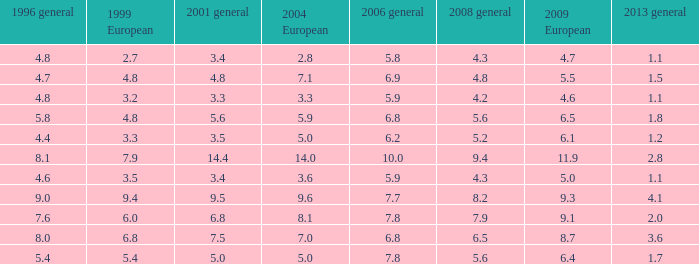How many values for 1999 European correspond to a value more than 4.7 in 2009 European, general 2001 more than 7.5, 2006 general at 10, and more than 9.4 in general 2008? 0.0. 